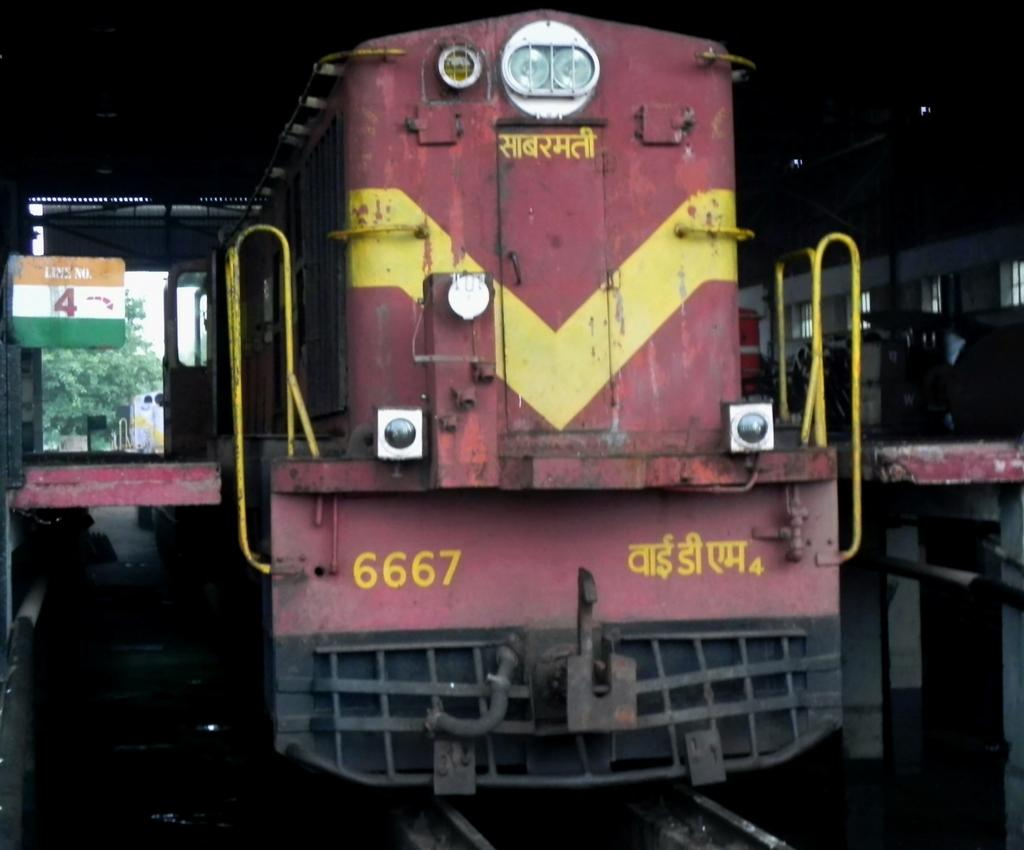What can be seen in the foreground of the image? There are trains on the track in the foreground of the image. What is visible in the background of the image? There are trees and the sky in the background of the image. Can you describe the time of day when the image was taken? The image is likely taken during the day, as the sky is visible. What type of punishment is being administered to the governor in the image? There is no governor or punishment present in the image; it features trains on a track with trees and sky in the background. 